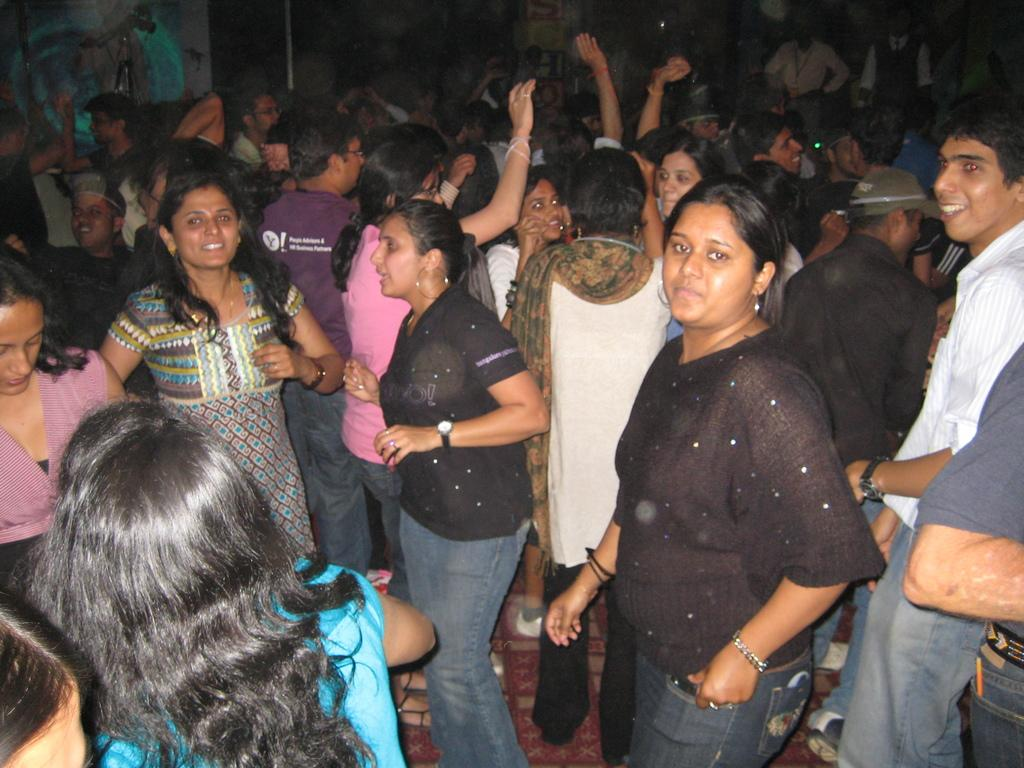How many people are in the image? There are a few people in the image. What can be seen under the people's feet in the image? The ground is visible in the image. What is located behind the people in the image? There is a wall in the background of the image. What else can be seen in the background of the image? There are some objects in the background of the image. What type of pets are being questioned by the people in the image? There are no pets present in the image, nor is there any indication that the people are questioning anything. 